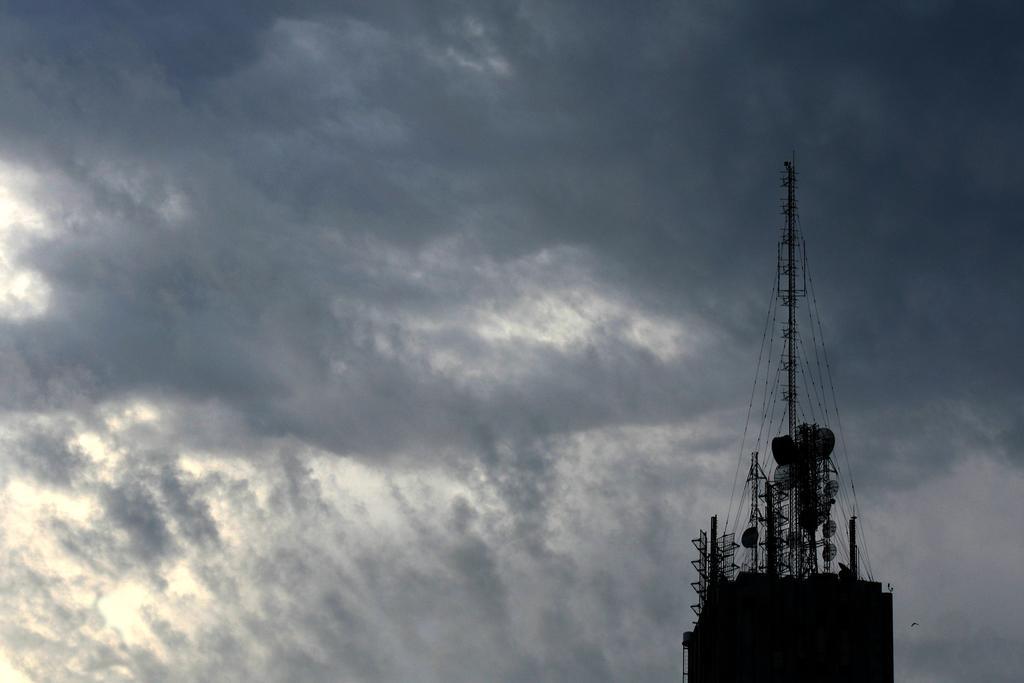Please provide a concise description of this image. In this picture I can see towers, and in the background there is the sky. 